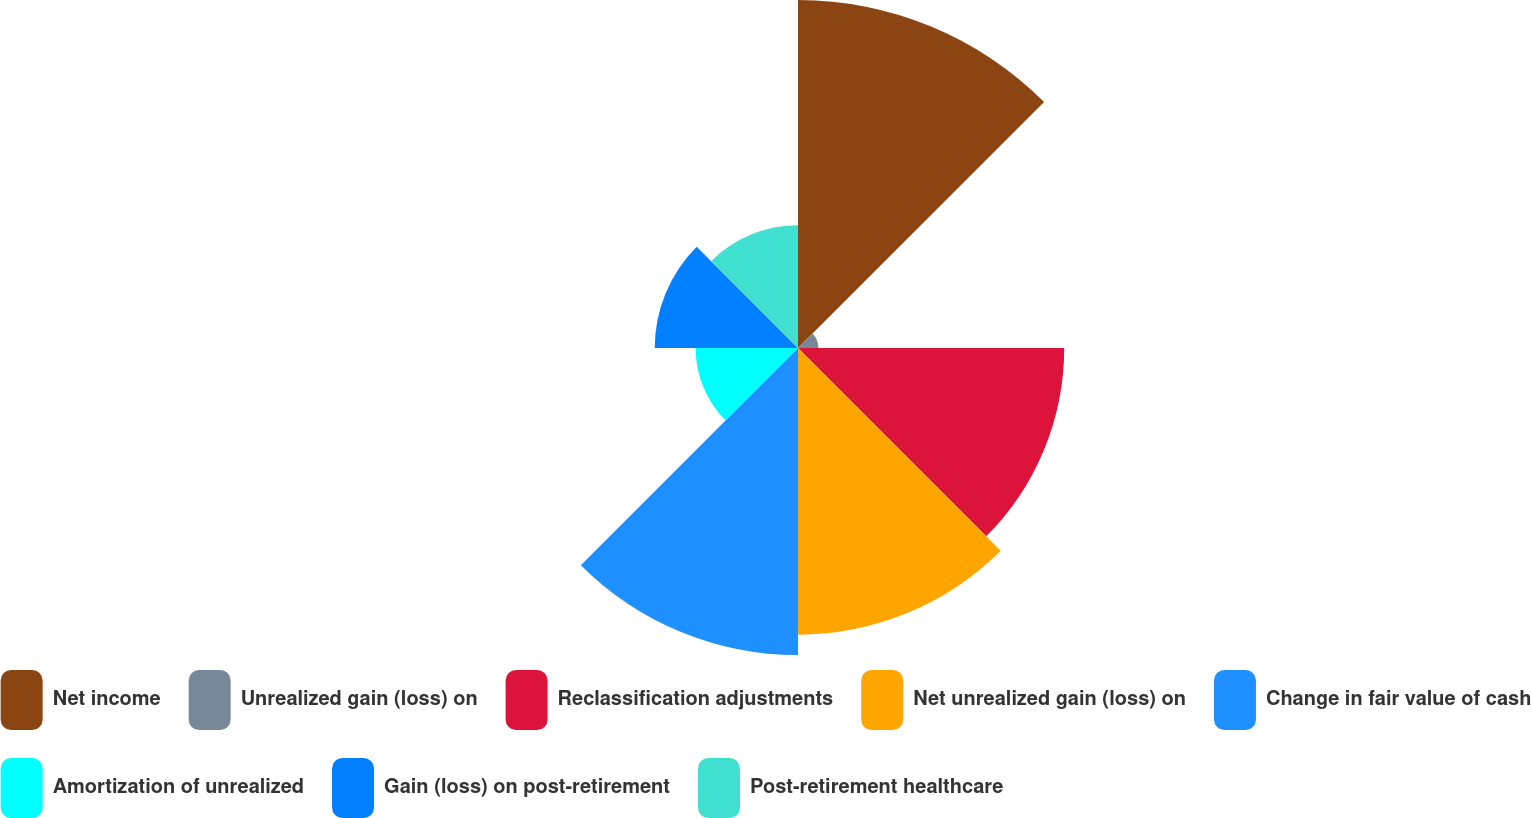Convert chart. <chart><loc_0><loc_0><loc_500><loc_500><pie_chart><fcel>Net income<fcel>Unrealized gain (loss) on<fcel>Reclassification adjustments<fcel>Net unrealized gain (loss) on<fcel>Change in fair value of cash<fcel>Amortization of unrealized<fcel>Gain (loss) on post-retirement<fcel>Post-retirement healthcare<nl><fcel>21.79%<fcel>1.28%<fcel>16.67%<fcel>17.95%<fcel>19.23%<fcel>6.41%<fcel>8.97%<fcel>7.69%<nl></chart> 